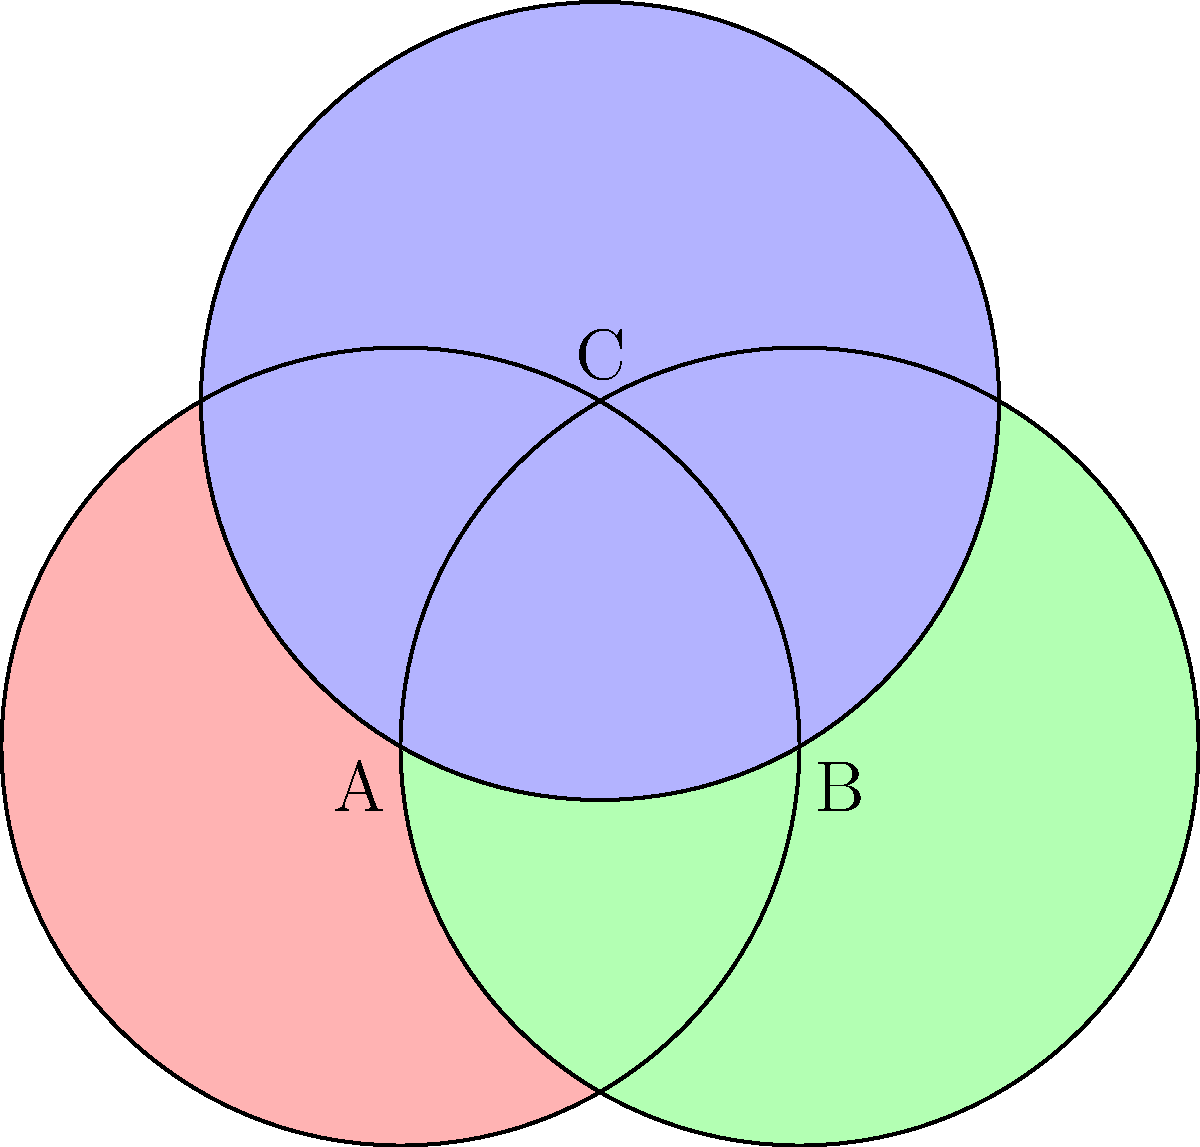In the context of your abstract artwork, consider three overlapping circular shapes A, B, and C as shown in the diagram. What is the fundamental group of the space formed by the union of these three shapes? To determine the fundamental group of this space, we'll follow these steps:

1) First, observe that the space is path-connected, as any two points can be connected by a path within the union of the circles.

2) The space formed by the union of these three circles is homotopy equivalent to a figure-eight shape, also known as a bouquet of two circles. This is because:
   a) The overlap regions don't create any enclosed areas.
   b) We can continuously deform this space into a figure-eight without changing its topological properties.

3) The fundamental group of a bouquet of $n$ circles is isomorphic to the free group on $n$ generators. In this case, we have a bouquet of 2 circles.

4) Therefore, the fundamental group of this space is isomorphic to the free group on 2 generators, denoted as $F_2$.

5) In abstract algebra notation, we can write this as:

   $$\pi_1(X) \cong F_2 = \langle a, b \rangle$$

   where $X$ is our space, and $a$ and $b$ are the generators corresponding to the two loops of the figure-eight.

This result implies that any loop in this space can be represented as a word in $a$ and $b$, corresponding to how many times and in what order the loop wraps around each of the two basic loops of the figure-eight.
Answer: $F_2$ (Free group on 2 generators) 